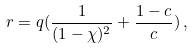Convert formula to latex. <formula><loc_0><loc_0><loc_500><loc_500>r = q ( \frac { 1 } { ( 1 - \chi ) ^ { 2 } } + \frac { 1 - c } { c } ) \, ,</formula> 